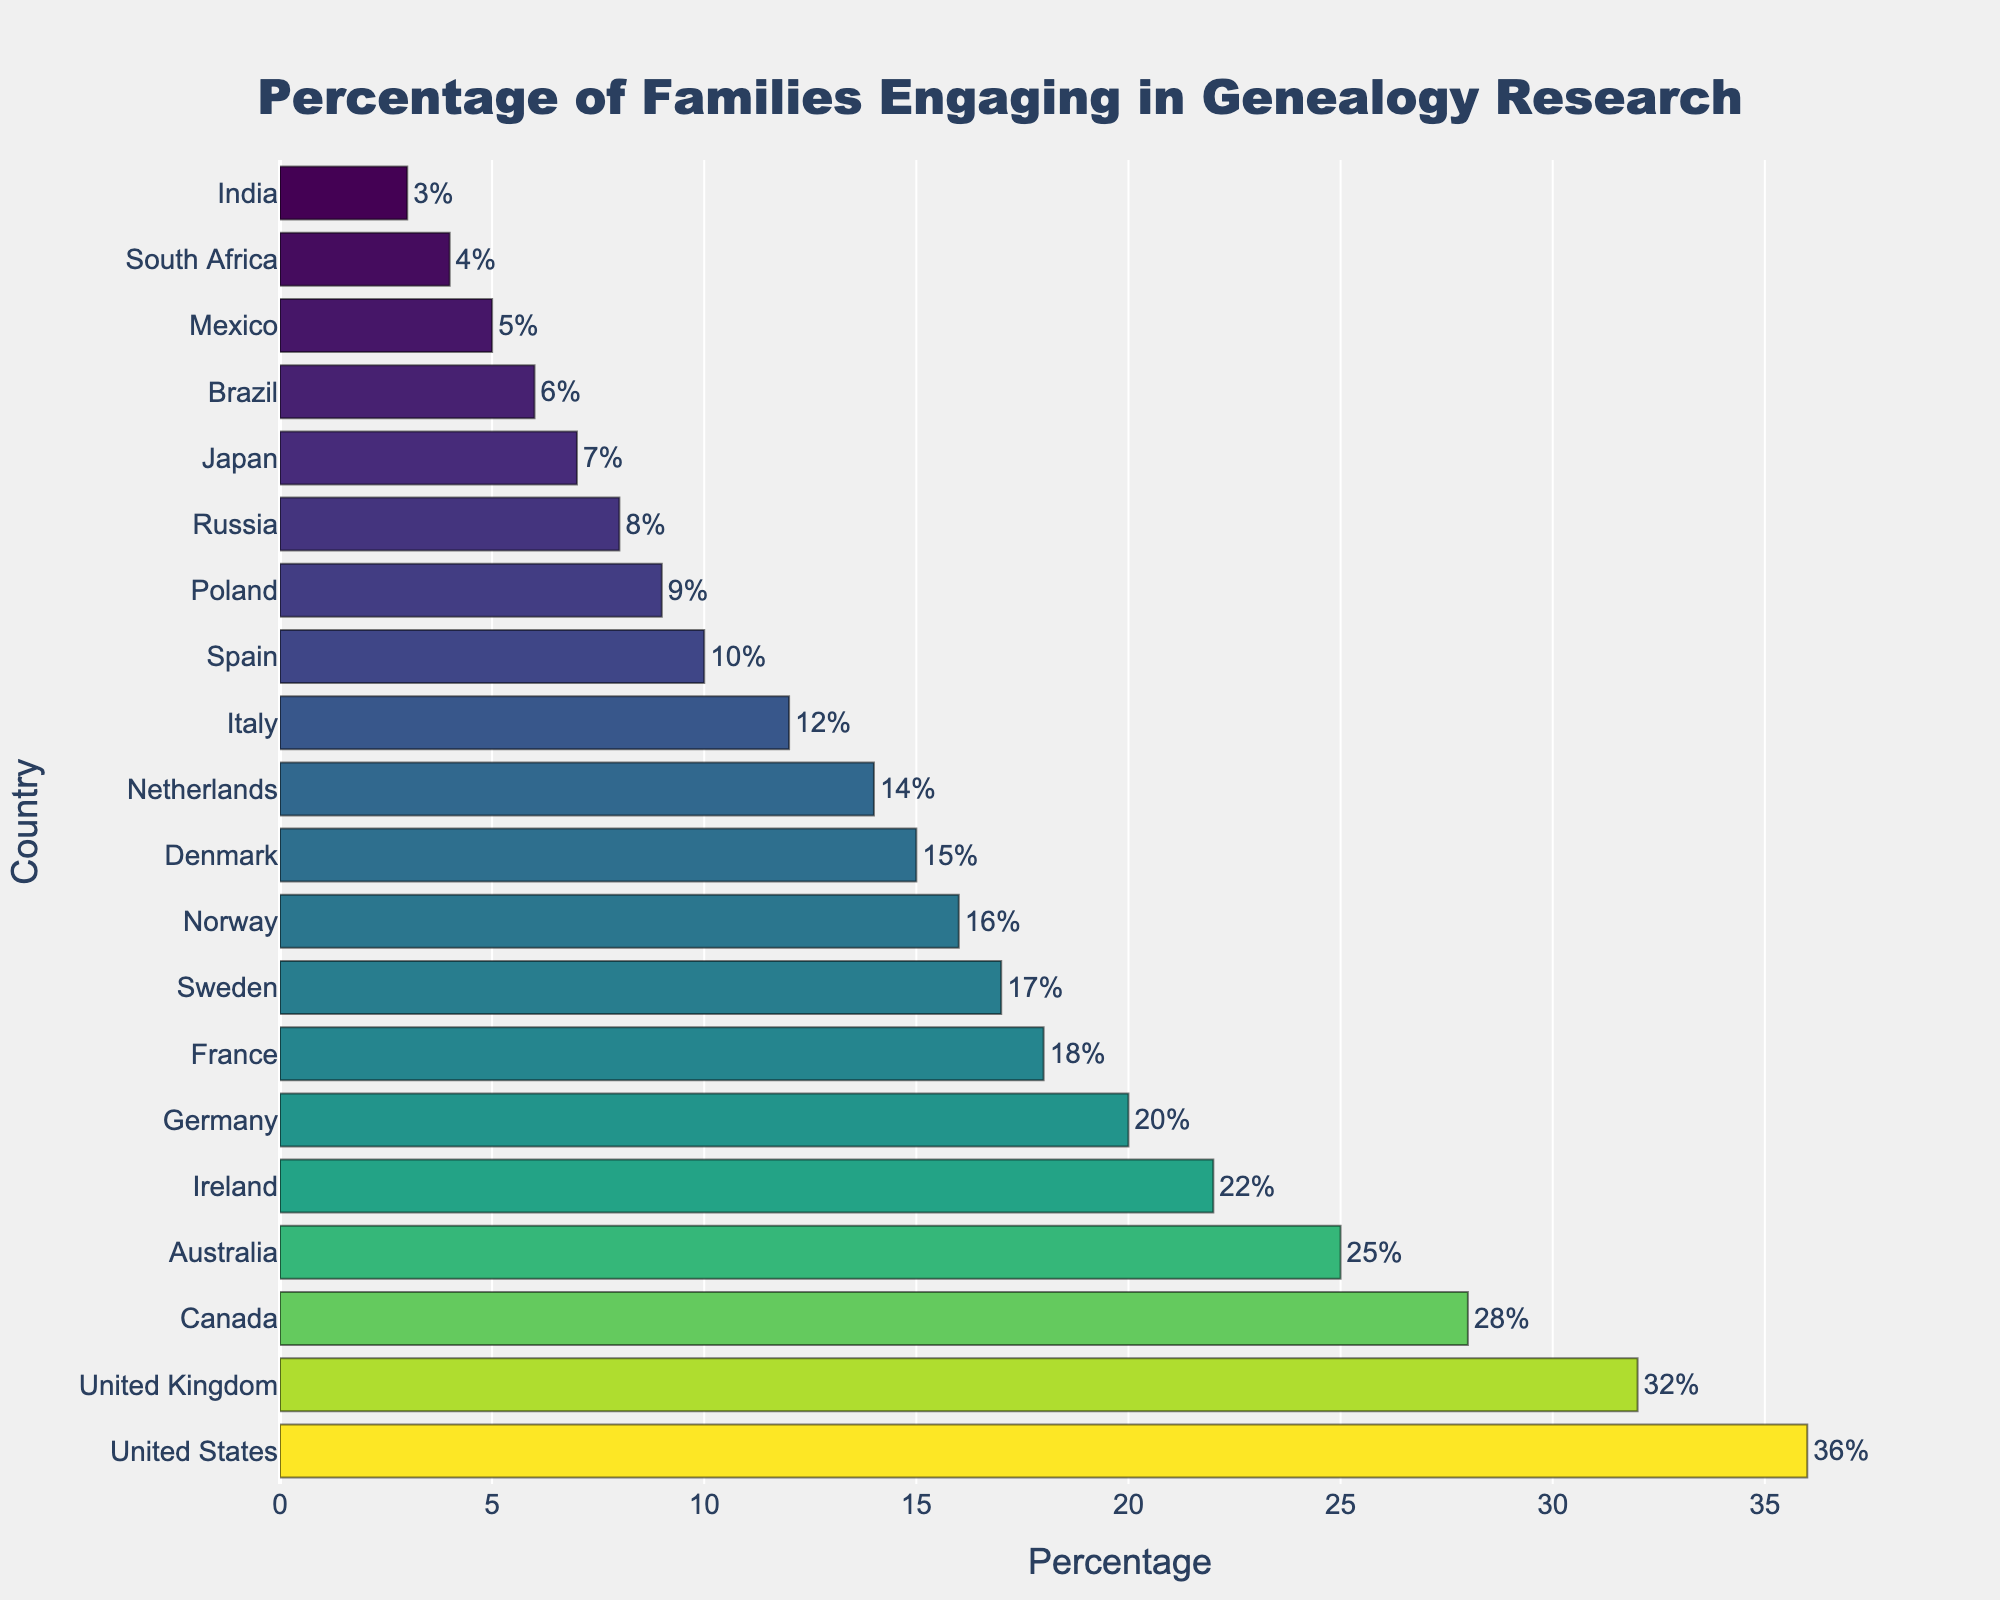Which country has the highest percentage of families engaging in genealogy research? The country with the highest percentage can be identified by looking at the bar with the greatest length, which represents the United States at 36%.
Answer: United States Which two countries have the same percentage of families engaging in genealogy research? By examining the lengths of the bars, we observe that Germany and France both have bars of the same length at 20% and 18% respectively.
Answer: None How much higher is the percentage of families engaging in genealogy research in the United States compared to Japan? To find this, subtract the percentage value for Japan (7%) from the percentage value for the United States (36%).
Answer: 29% What is the average percentage of families engaging in genealogy research in Canada, Australia, and Ireland? First, add the percentages for Canada (28%), Australia (25%), and Ireland (22%) to get 75%. Then, divide by 3 to find the average.
Answer: 25% In terms of genealogy research engagement, which country performs better: Sweden or Norway? By comparing the length of the bars, Sweden has a higher percentage (17%) compared to Norway (16%).
Answer: Sweden What is the difference in the percentage of families engaging in genealogy research between the United Kingdom and Italy? Subtract Italy's percentage (12%) from the United Kingdom's percentage (32%) to get the difference.
Answer: 20% Which country has a percentage of engagement closest to the median value on the list? Arrange the percentages in ascending order, the median falls between 16% (Norway) and 17% (Sweden), so the closest countries are Norway and Sweden.
Answer: Sweden and Norway Between Mexico and South Africa, which country has a lower percentage of families engaging in genealogy research? Compare the bars for both countries; Mexico has 5% and South Africa has 4%. Thus, South Africa has the lower percentage.
Answer: South Africa How does the percentage of families in Italy engaging in genealogy research compare to that of Denmark and Germany combined? Add the percentages for Denmark (15%) and Germany (20%) to get 35%. Italy's percentage is 12%, so it's significantly lower.
Answer: Significantly lower Visually, which country's bar is colored the darkest in the 'Viridis' colorscale employed in the figure? The darkest color typically represents the highest value, which here corresponds to the bar for the United States at 36%.
Answer: United States 